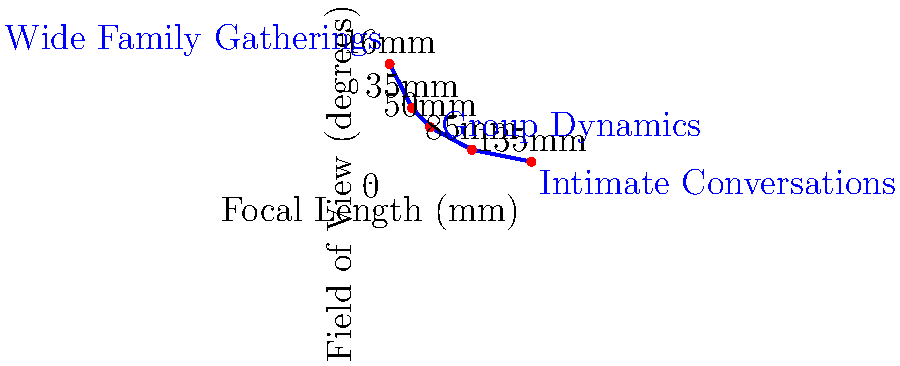Analyze the focal length comparison chart for family interaction scenarios. Which focal length would be most suitable for capturing subtle facial expressions and emotional nuances during a one-on-one conversation between family members, while maintaining a comfortable distance? To answer this question, we need to consider the following factors:

1. Focal length affects the field of view and perspective compression.
2. Longer focal lengths create more background compression and narrower fields of view.
3. Shorter focal lengths provide wider fields of view but can distort facial features.
4. For capturing subtle facial expressions, we want a focal length that:
   a) Provides a flattering perspective for faces
   b) Allows for a comfortable distance between the camera and subjects
   c) Creates some background separation without completely isolating the subjects

5. Looking at the chart:
   - 16mm and 35mm are too wide for intimate conversations, potentially distorting faces.
   - 50mm provides a natural perspective but may be too wide for subtle expressions.
   - 135mm is very narrow and might require too much distance between the camera and subjects.
   - 85mm offers a good balance:
     * It provides a flattering perspective for faces.
     * It allows for a comfortable working distance.
     * It offers some background separation without complete isolation.
     * The field of view (28°) is narrow enough to focus on facial expressions without being too restrictive.

6. Therefore, the 85mm focal length would be the most suitable for capturing subtle facial expressions and emotional nuances during a one-on-one conversation between family members.
Answer: 85mm 